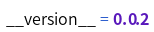<code> <loc_0><loc_0><loc_500><loc_500><_Python_>__version__ = 0.0.2
</code> 